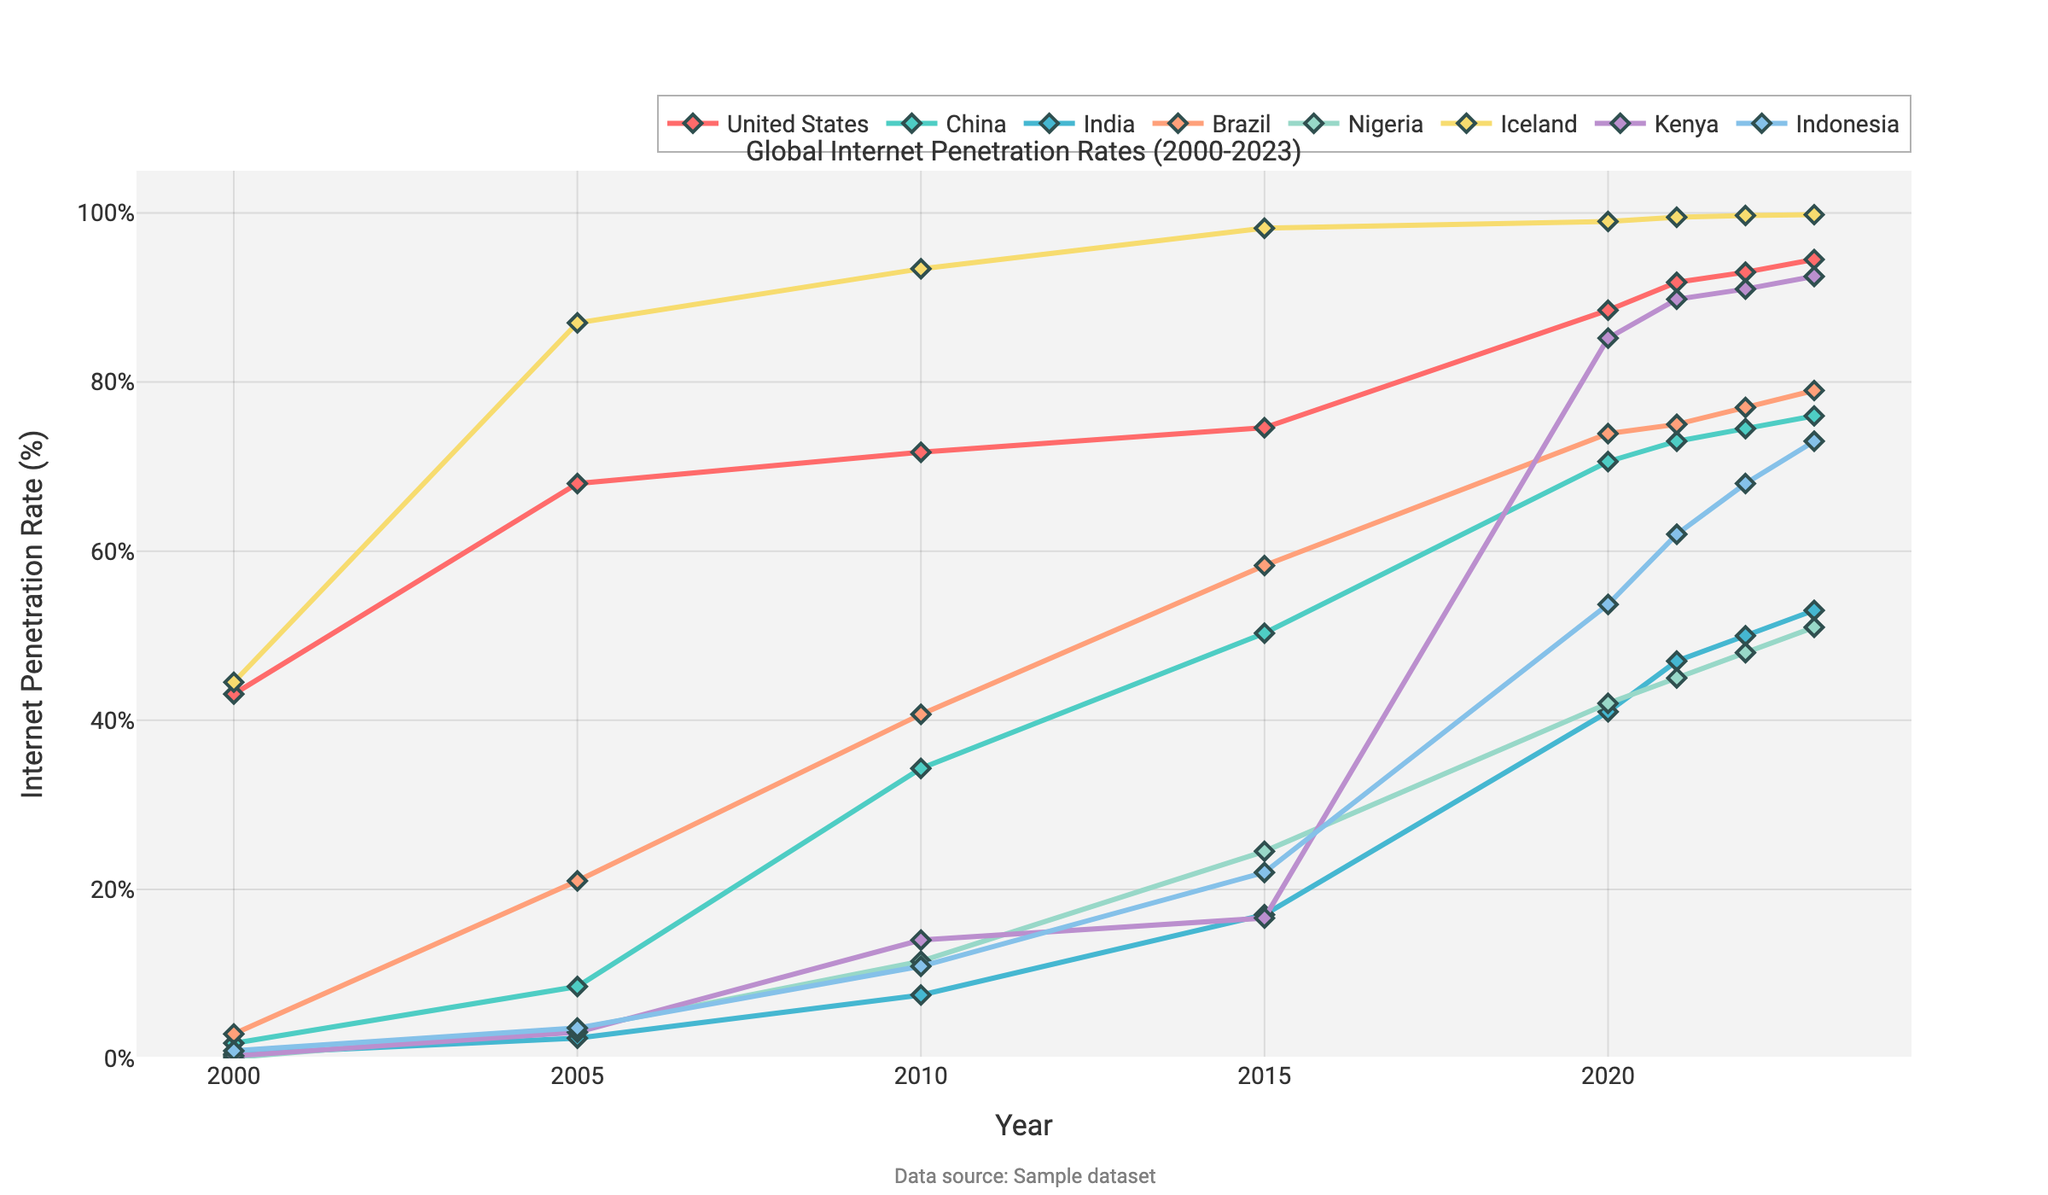How did the internet penetration rate change in the United States from 2000 to 2023? In 2000, the penetration rate in the United States was 43.1%. By 2023, it increased to 94.5%. The difference is 94.5% - 43.1% = 51.4%.
Answer: 51.4% Which country had the highest internet penetration rate in 2023? Observing the end point of each line for 2023, Iceland has the highest rate at 99.8%.
Answer: Iceland Compare the internet penetration rates of China and India in 2015. Which country had a higher rate and by how much? In 2015, China's rate was 50.3% and India's was 17.0%. The difference is 50.3% - 17.0% = 33.3%.
Answer: China, 33.3% What is the average internet penetration rate of Kenya over the years 2000, 2005, and 2010? The rates for Kenya in these years are 0.3%, 3.1%, and 14.0%. The average is (0.3 + 3.1 + 14.0) / 3 = 5.8%.
Answer: 5.8% Between which consecutive years did Nigeria experience the highest increase in internet penetration rate? Noting the values, the largest increase occurred between 2015 and 2020, from 24.5% to 42.0%, which is an increase of 42.0% - 24.5% = 17.5%.
Answer: 2015 to 2020 Which country showed the most consistent growth in internet penetration rates from 2000 to 2023? Upon examining the trends, Iceland shows steady growth with high values throughout, indicating consistent growth.
Answer: Iceland In 2020, which country had a lower rate of internet penetration, Indonesia or Brazil? By how much? In 2020, Brazil's rate was 73.9% and Indonesia's was 53.7%. The difference is 73.9% - 53.7% = 20.2%.
Answer: Indonesia, 20.2% What is the total increase in internet penetration rate for Indonesia from 2010 to 2023? The rate in 2010 is 10.9%, and in 2023 it is 73.0%. The total increase is 73.0% - 10.9% = 62.1%.
Answer: 62.1% How does the internet penetration rate in Kenya compare with the United States in 2023? In 2023, Kenya's rate is 92.5% and the United States is 94.5%. The difference is 94.5% - 92.5% = 2.0%.
Answer: United States, 2.0% Which year did Brazil's internet penetration rate first exceed 50%? Checking the data, in 2015 Brazil's rate was 58.3%, which is the first year it exceeded 50%.
Answer: 2015 